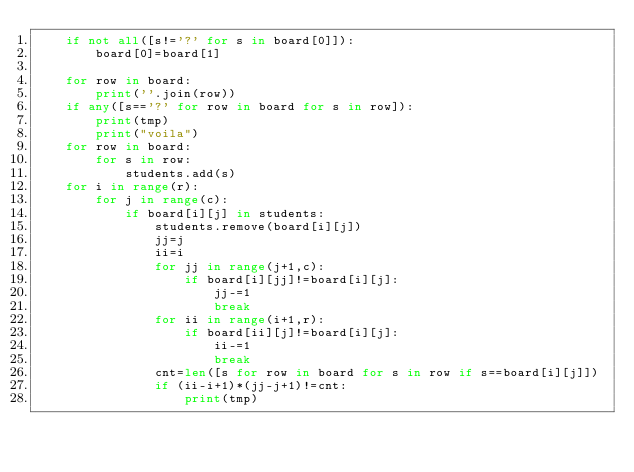Convert code to text. <code><loc_0><loc_0><loc_500><loc_500><_Python_>    if not all([s!='?' for s in board[0]]):
        board[0]=board[1]
        
    for row in board:
        print(''.join(row))
    if any([s=='?' for row in board for s in row]):
        print(tmp)
        print("voila")
    for row in board:
        for s in row:
            students.add(s)
    for i in range(r):
        for j in range(c):
            if board[i][j] in students:
                students.remove(board[i][j])
                jj=j
                ii=i
                for jj in range(j+1,c):
                    if board[i][jj]!=board[i][j]:
                        jj-=1
                        break
                for ii in range(i+1,r):
                    if board[ii][j]!=board[i][j]:
                        ii-=1
                        break
                cnt=len([s for row in board for s in row if s==board[i][j]])
                if (ii-i+1)*(jj-j+1)!=cnt:
                    print(tmp)</code> 